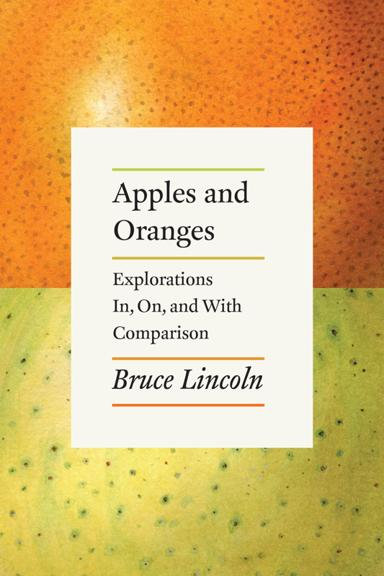What is the image on the poster? It appears there has been a misunderstanding, as the image does not display any poster. The image solely focuses on the cover of the book titled 'Apples and Oranges' by Bruce Lincoln. 